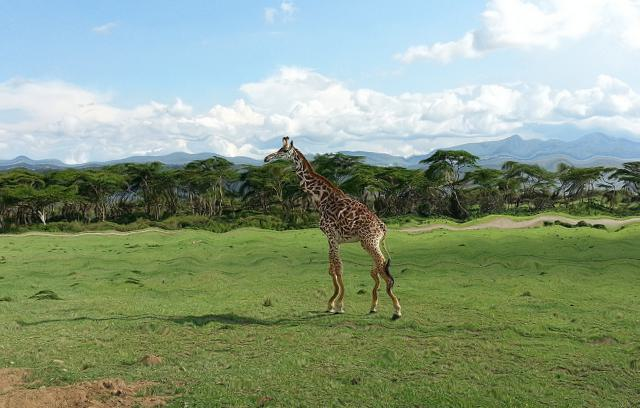How does the giraffe's physical appearance contribute to its survival in this environment? The giraffe's long neck and legs are evolutionarily advantageous, allowing it to reach foliage that other animals can't and to spot predators from a distance. Its spotted coat provides camouflage among the light and shadows created by the savanna's foliage, helping it blend into the background and avoid detection by predators. 